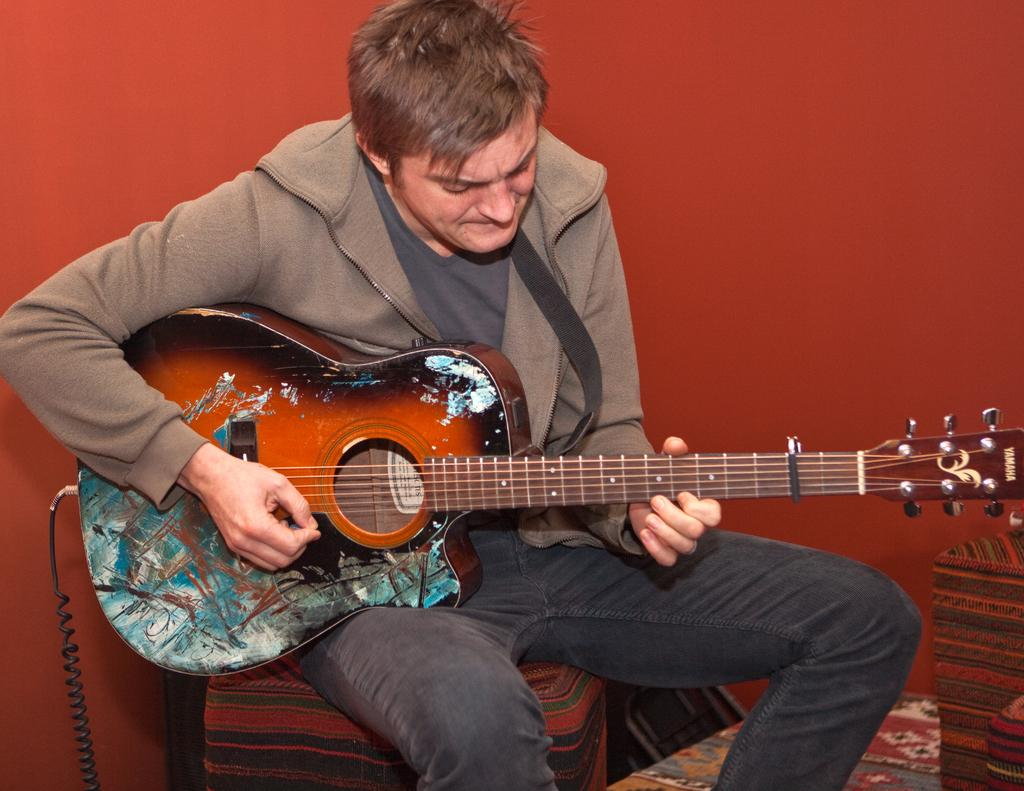Who is the main subject in the image? There is a man in the image. What is the man doing in the image? The man is sitting in a chair and playing a guitar. Can you describe the chair the man is sitting on? There is a chair in the background of the image, but it is not the one the man is sitting on. What can be seen in the background of the image? There is a wall in the background of the image. What type of harmony is the man trying to achieve with his voyage in the image? There is no mention of a voyage or harmony in the image; the man is simply playing a guitar while sitting in a chair. 